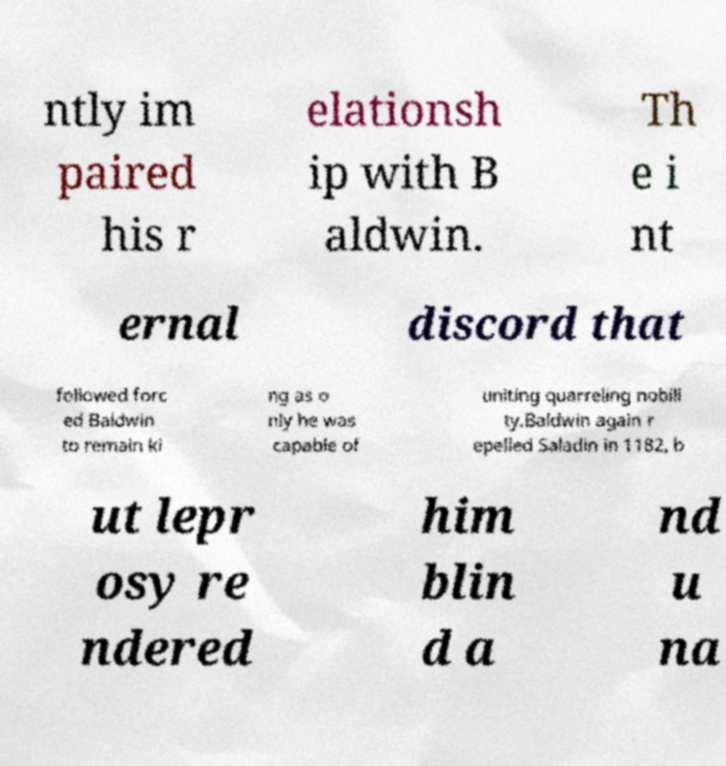For documentation purposes, I need the text within this image transcribed. Could you provide that? ntly im paired his r elationsh ip with B aldwin. Th e i nt ernal discord that followed forc ed Baldwin to remain ki ng as o nly he was capable of uniting quarreling nobili ty.Baldwin again r epelled Saladin in 1182, b ut lepr osy re ndered him blin d a nd u na 